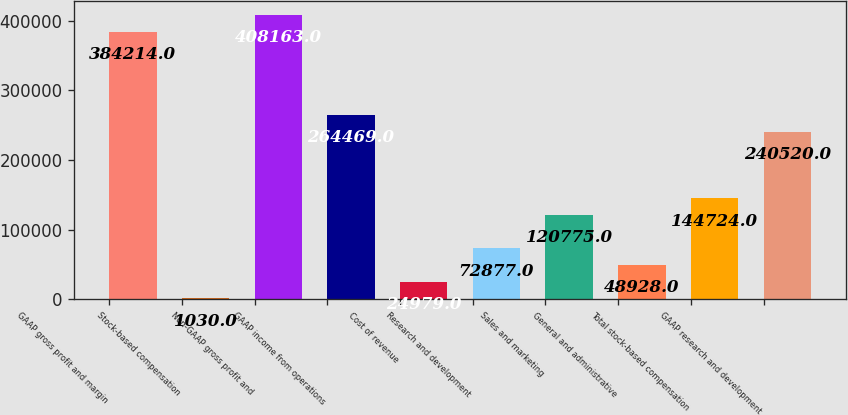Convert chart to OTSL. <chart><loc_0><loc_0><loc_500><loc_500><bar_chart><fcel>GAAP gross profit and margin<fcel>Stock-based compensation<fcel>Non-GAAP gross profit and<fcel>GAAP income from operations<fcel>Cost of revenue<fcel>Research and development<fcel>Sales and marketing<fcel>General and administrative<fcel>Total stock-based compensation<fcel>GAAP research and development<nl><fcel>384214<fcel>1030<fcel>408163<fcel>264469<fcel>24979<fcel>72877<fcel>120775<fcel>48928<fcel>144724<fcel>240520<nl></chart> 